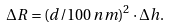<formula> <loc_0><loc_0><loc_500><loc_500>\Delta R = ( d / 1 0 0 \, n m ) ^ { 2 } \cdot \Delta h .</formula> 